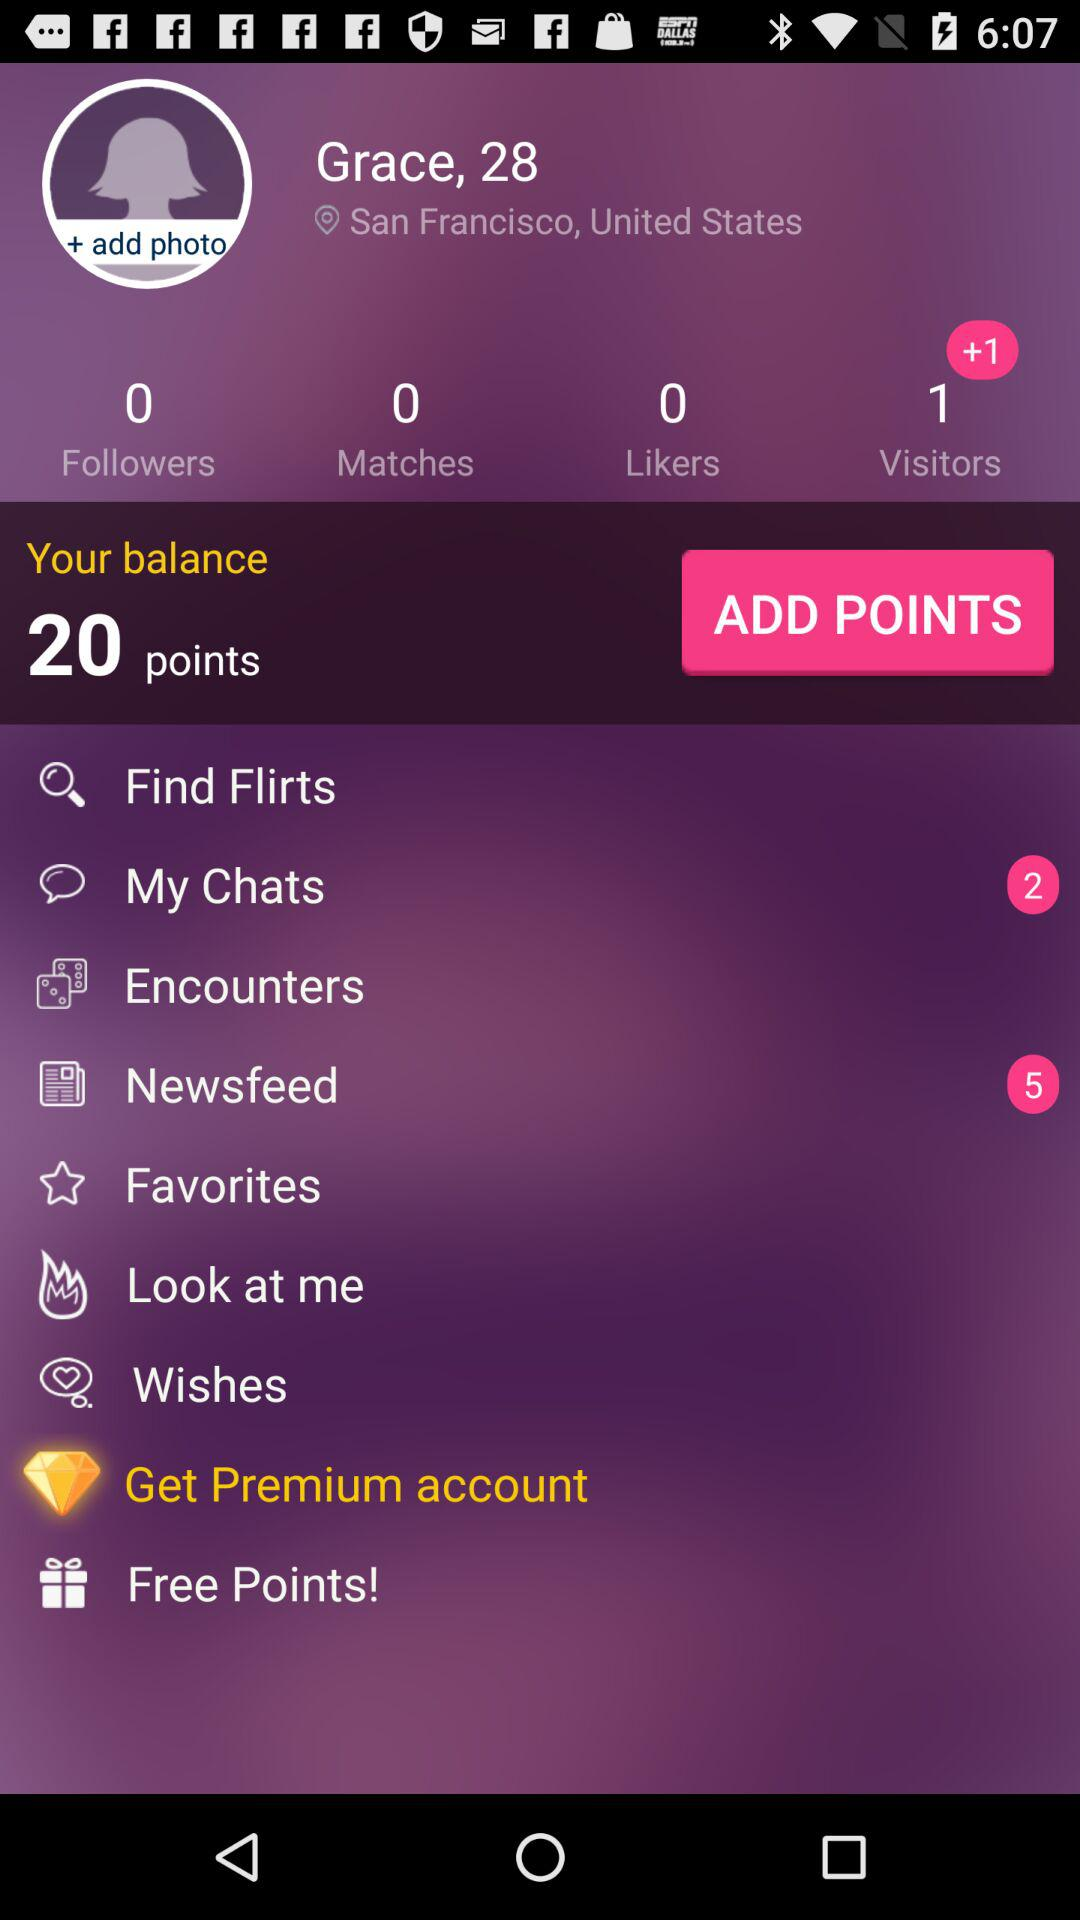What is the mentioned age? The mentioned age is 28. 